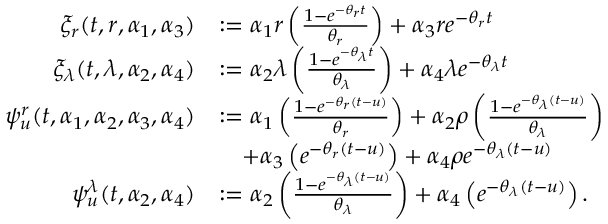<formula> <loc_0><loc_0><loc_500><loc_500>\begin{array} { r l } { \xi _ { r } ( t , r , \alpha _ { 1 } , \alpha _ { 3 } ) } & { \colon = \alpha _ { 1 } r \left ( \frac { 1 - e ^ { - \theta _ { r } t } } { \theta _ { r } } \right ) + \alpha _ { 3 } r e ^ { - \theta _ { r } t } } \\ { \xi _ { \lambda } ( t , \lambda , \alpha _ { 2 } , \alpha _ { 4 } ) } & { \colon = \alpha _ { 2 } \lambda \left ( \frac { 1 - e ^ { - \theta _ { \lambda } t } } { \theta _ { \lambda } } \right ) + \alpha _ { 4 } \lambda e ^ { - \theta _ { \lambda } t } } \\ { \psi _ { u } ^ { r } ( t , \alpha _ { 1 } , \alpha _ { 2 } , \alpha _ { 3 } , \alpha _ { 4 } ) } & { \colon = \alpha _ { 1 } \left ( \frac { 1 - e ^ { - \theta _ { r } ( t - u ) } } { \theta _ { r } } \right ) + \alpha _ { 2 } \rho \left ( \frac { 1 - e ^ { - \theta _ { \lambda } ( t - u ) } } { \theta _ { \lambda } } \right ) } \\ & { \quad + \alpha _ { 3 } \left ( e ^ { - \theta _ { r } ( t - u ) } \right ) + \alpha _ { 4 } \rho e ^ { - \theta _ { \lambda } ( t - u ) } } \\ { \psi _ { u } ^ { \lambda } ( t , \alpha _ { 2 } , \alpha _ { 4 } ) } & { \colon = \alpha _ { 2 } \left ( \frac { 1 - e ^ { - \theta _ { \lambda } ( t - u ) } } { \theta _ { \lambda } } \right ) + \alpha _ { 4 } \left ( e ^ { - \theta _ { \lambda } ( t - u ) } \right ) . } \end{array}</formula> 